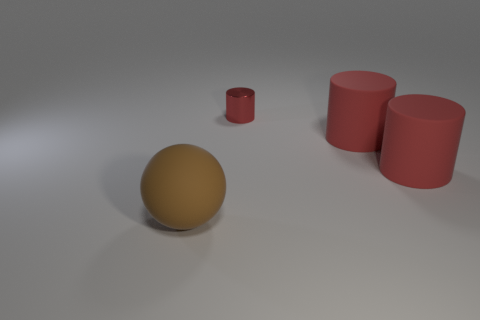Is the number of large rubber cylinders greater than the number of large objects?
Your response must be concise. No. Is there a big cyan metallic thing?
Your response must be concise. No. What number of objects are either red objects that are in front of the small red object or big objects behind the big brown ball?
Your answer should be compact. 2. Are there fewer small gray matte things than large red matte cylinders?
Make the answer very short. Yes. Are there any red things in front of the matte ball?
Make the answer very short. No. How many big brown things have the same material as the large sphere?
Make the answer very short. 0. There is a matte sphere; how many big spheres are in front of it?
Offer a very short reply. 0. The matte sphere has what size?
Your response must be concise. Large. Are there any shiny things of the same color as the tiny cylinder?
Offer a very short reply. No. What is the material of the tiny thing?
Ensure brevity in your answer.  Metal. 